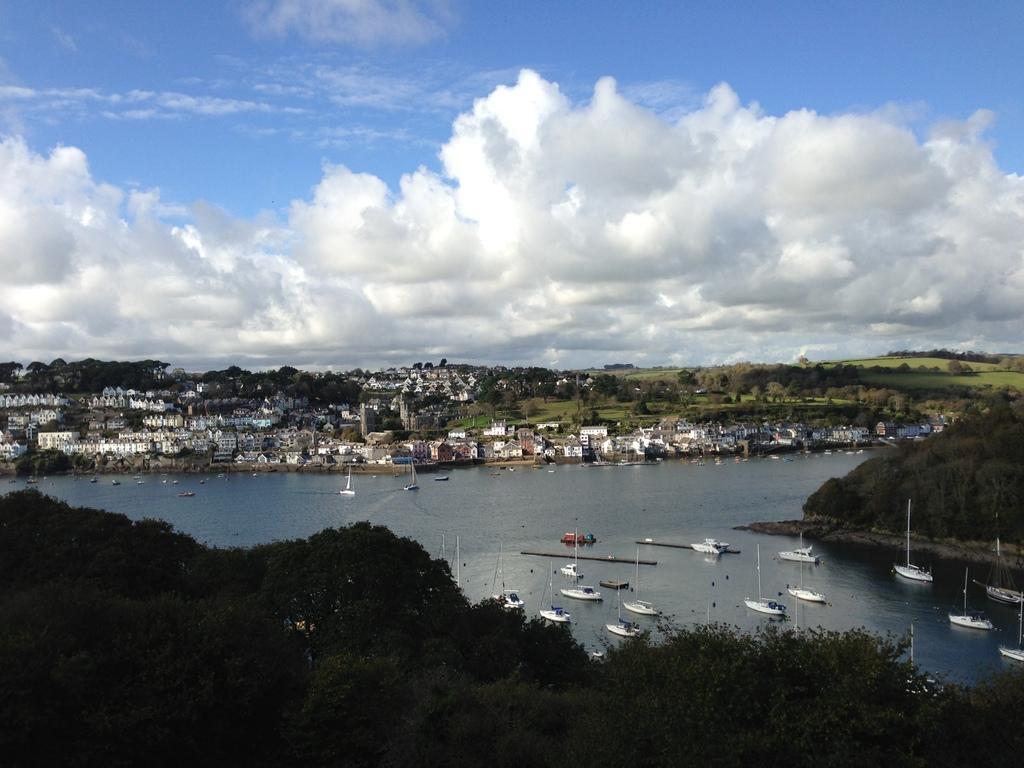How would you summarize this image in a sentence or two? In this picture there are trees at the bottom side of the image and there are ships on the water at the bottom side of the image, there are houses and trees in the background area of the image and there is sky at the top side of the image. 